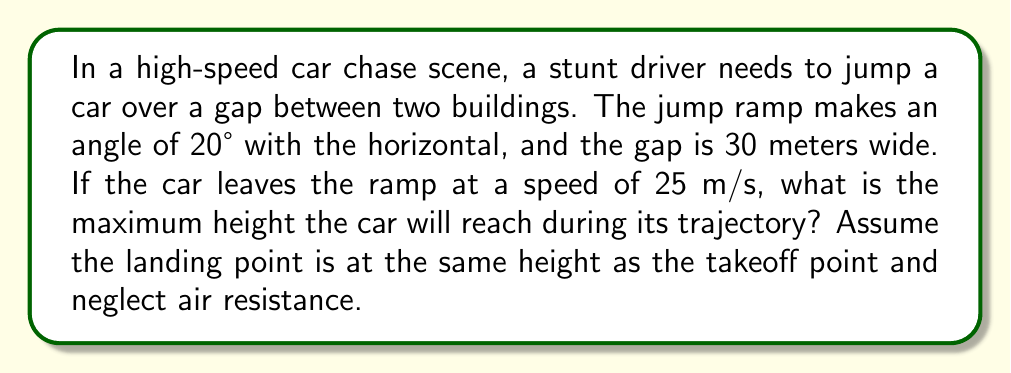Can you answer this question? To solve this problem, we'll use projectile motion equations and trigonometry. Let's break it down step-by-step:

1) First, we need to find the initial vertical and horizontal velocities:
   $v_{0x} = v_0 \cos(\theta) = 25 \cos(20°)$
   $v_{0y} = v_0 \sin(\theta) = 25 \sin(20°)$

2) The time of flight can be calculated using the horizontal distance and velocity:
   $t = \frac{d}{v_{0x}} = \frac{30}{25 \cos(20°)}$

3) The maximum height occurs at half the time of flight. We can use the equation:
   $h = v_{0y}(\frac{t}{2}) - \frac{1}{2}g(\frac{t}{2})^2$

   Where $g$ is the acceleration due to gravity (9.8 m/s²).

4) Substituting the values:
   $h = 25 \sin(20°) \cdot \frac{30}{2 \cdot 25 \cos(20°)} - \frac{1}{2} \cdot 9.8 \cdot (\frac{30}{2 \cdot 25 \cos(20°)})^2$

5) Simplifying:
   $h = \frac{15 \sin(20°)}{\cos(20°)} - \frac{9.8 \cdot 225}{2 \cdot 25^2 \cos^2(20°)}$

6) Calculating:
   $h \approx 5.46 - 1.82 = 3.64$ meters

Therefore, the maximum height the car will reach during its trajectory is approximately 3.64 meters.
Answer: 3.64 meters 